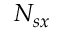Convert formula to latex. <formula><loc_0><loc_0><loc_500><loc_500>N _ { s x }</formula> 